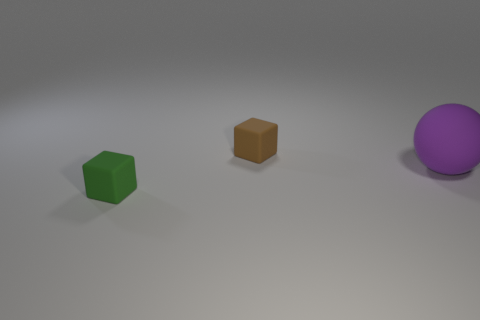There is a rubber thing on the right side of the small brown block; does it have the same size as the cube behind the large purple thing?
Provide a succinct answer. No. There is a tiny green block that is to the left of the big purple thing; is there a purple matte sphere that is behind it?
Offer a very short reply. Yes. There is a brown rubber thing; what number of brown cubes are in front of it?
Give a very brief answer. 0. What number of other things are the same color as the matte sphere?
Your response must be concise. 0. Is the number of matte objects to the right of the tiny green cube less than the number of rubber objects on the right side of the tiny brown rubber cube?
Provide a short and direct response. No. How many objects are either small objects on the right side of the tiny green block or small cubes?
Keep it short and to the point. 2. Is the size of the brown rubber cube the same as the purple matte object that is behind the small green rubber object?
Provide a succinct answer. No. There is another rubber object that is the same shape as the green matte object; what size is it?
Offer a very short reply. Small. What number of small rubber blocks are behind the small matte thing behind the small object that is in front of the small brown object?
Offer a terse response. 0. How many cylinders are tiny green matte objects or large matte objects?
Give a very brief answer. 0. 